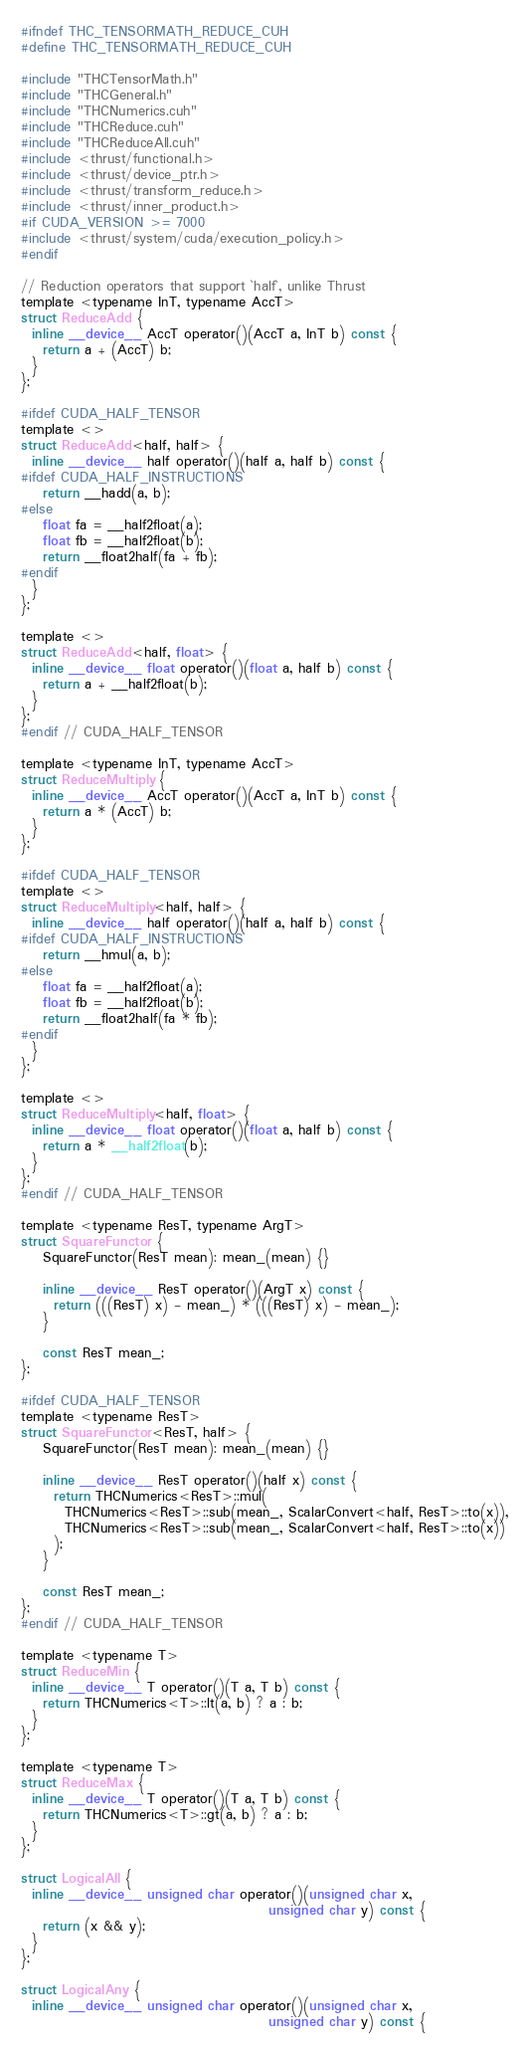Convert code to text. <code><loc_0><loc_0><loc_500><loc_500><_Cuda_>#ifndef THC_TENSORMATH_REDUCE_CUH
#define THC_TENSORMATH_REDUCE_CUH

#include "THCTensorMath.h"
#include "THCGeneral.h"
#include "THCNumerics.cuh"
#include "THCReduce.cuh"
#include "THCReduceAll.cuh"
#include <thrust/functional.h>
#include <thrust/device_ptr.h>
#include <thrust/transform_reduce.h>
#include <thrust/inner_product.h>
#if CUDA_VERSION >= 7000
#include <thrust/system/cuda/execution_policy.h>
#endif

// Reduction operators that support `half`, unlike Thrust
template <typename InT, typename AccT>
struct ReduceAdd {
  inline __device__ AccT operator()(AccT a, InT b) const {
    return a + (AccT) b;
  }
};

#ifdef CUDA_HALF_TENSOR
template <>
struct ReduceAdd<half, half> {
  inline __device__ half operator()(half a, half b) const {
#ifdef CUDA_HALF_INSTRUCTIONS
    return __hadd(a, b);
#else
    float fa = __half2float(a);
    float fb = __half2float(b);
    return __float2half(fa + fb);
#endif
  }
};

template <>
struct ReduceAdd<half, float> {
  inline __device__ float operator()(float a, half b) const {
    return a + __half2float(b);
  }
};
#endif // CUDA_HALF_TENSOR

template <typename InT, typename AccT>
struct ReduceMultiply {
  inline __device__ AccT operator()(AccT a, InT b) const {
    return a * (AccT) b;
  }
};

#ifdef CUDA_HALF_TENSOR
template <>
struct ReduceMultiply<half, half> {
  inline __device__ half operator()(half a, half b) const {
#ifdef CUDA_HALF_INSTRUCTIONS
    return __hmul(a, b);
#else
    float fa = __half2float(a);
    float fb = __half2float(b);
    return __float2half(fa * fb);
#endif
  }
};

template <>
struct ReduceMultiply<half, float> {
  inline __device__ float operator()(float a, half b) const {
    return a * __half2float(b);
  }
};
#endif // CUDA_HALF_TENSOR

template <typename ResT, typename ArgT>
struct SquareFunctor {
    SquareFunctor(ResT mean): mean_(mean) {}

    inline __device__ ResT operator()(ArgT x) const {
      return (((ResT) x) - mean_) * (((ResT) x) - mean_);
    }

    const ResT mean_;
};

#ifdef CUDA_HALF_TENSOR
template <typename ResT>
struct SquareFunctor<ResT, half> {
    SquareFunctor(ResT mean): mean_(mean) {}

    inline __device__ ResT operator()(half x) const {
      return THCNumerics<ResT>::mul(
        THCNumerics<ResT>::sub(mean_, ScalarConvert<half, ResT>::to(x)),
        THCNumerics<ResT>::sub(mean_, ScalarConvert<half, ResT>::to(x))
      );
    }

    const ResT mean_;
};
#endif // CUDA_HALF_TENSOR

template <typename T>
struct ReduceMin {
  inline __device__ T operator()(T a, T b) const {
    return THCNumerics<T>::lt(a, b) ? a : b;
  }
};

template <typename T>
struct ReduceMax {
  inline __device__ T operator()(T a, T b) const {
    return THCNumerics<T>::gt(a, b) ? a : b;
  }
};

struct LogicalAll {
  inline __device__ unsigned char operator()(unsigned char x,
                                             unsigned char y) const {
    return (x && y);
  }
};

struct LogicalAny {
  inline __device__ unsigned char operator()(unsigned char x,
                                             unsigned char y) const {</code> 